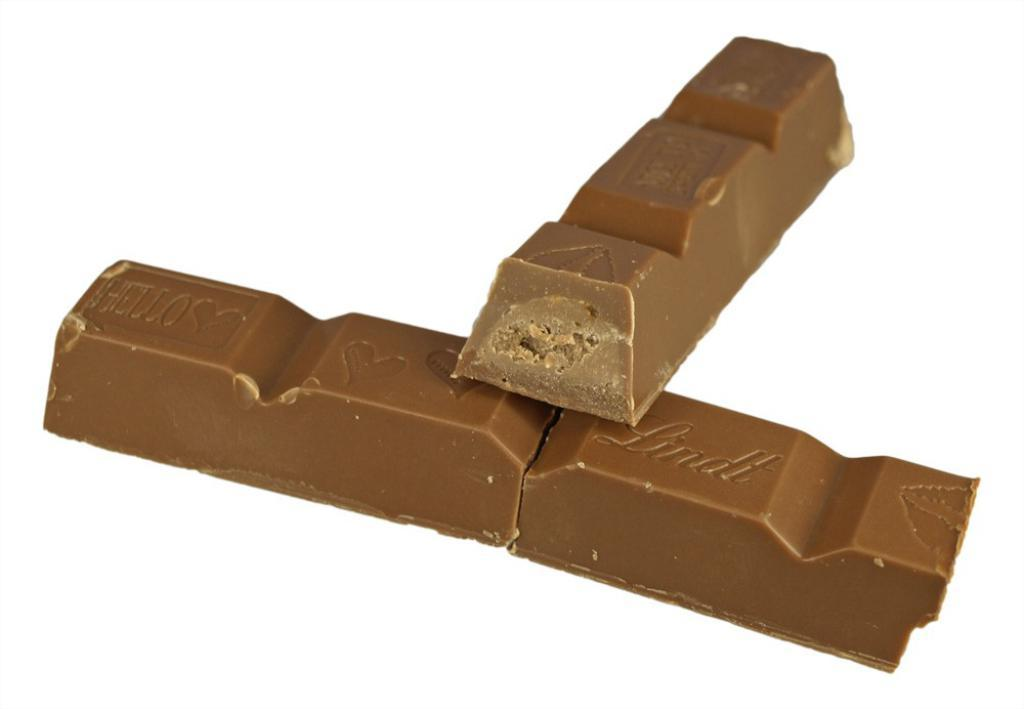What type of food items are present in the image? There are two chocolate bars in the image. What is the color of the chocolate bars? The chocolate bars are brown in color. What color is the background of the image? The background of the image is white. What type of meat is being cooked in the image? There is no meat present in the image; it only features two chocolate bars. What is the source of fear in the image? There is no fear depicted in the image; it is simply a picture of two chocolate bars on a white background. 